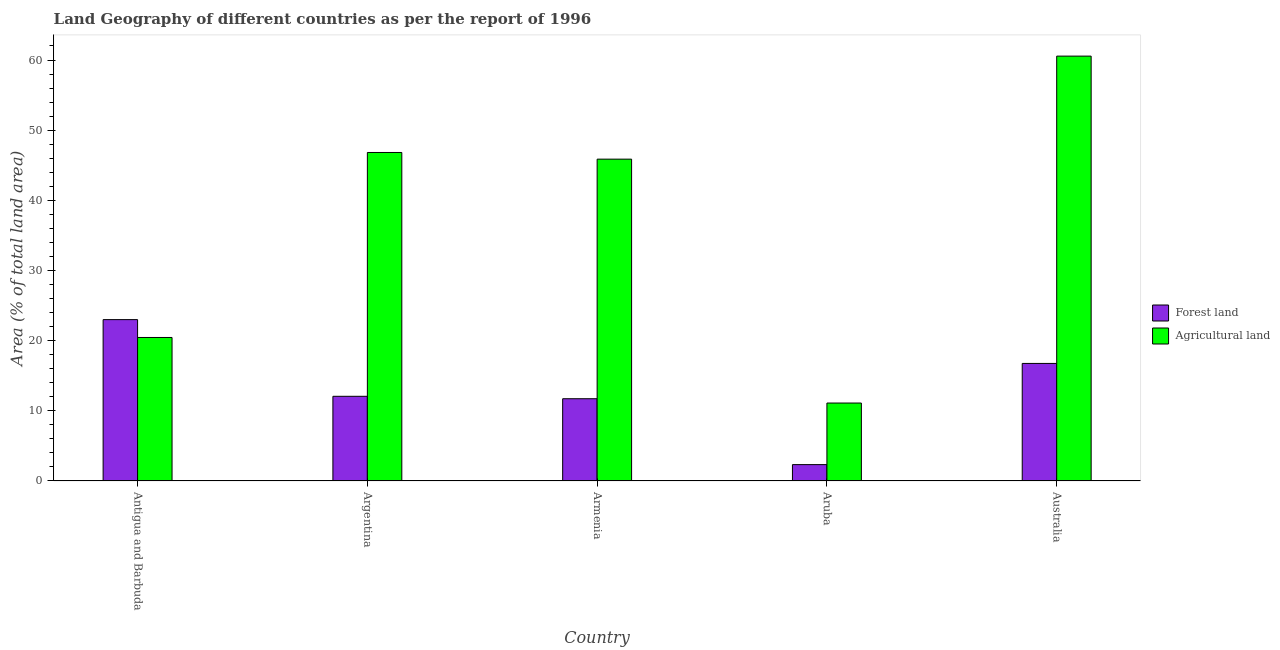How many different coloured bars are there?
Provide a short and direct response. 2. How many groups of bars are there?
Ensure brevity in your answer.  5. Are the number of bars on each tick of the X-axis equal?
Your response must be concise. Yes. What is the label of the 1st group of bars from the left?
Offer a terse response. Antigua and Barbuda. In how many cases, is the number of bars for a given country not equal to the number of legend labels?
Your answer should be very brief. 0. What is the percentage of land area under agriculture in Antigua and Barbuda?
Offer a very short reply. 20.45. Across all countries, what is the minimum percentage of land area under agriculture?
Your answer should be compact. 11.11. In which country was the percentage of land area under forests minimum?
Provide a succinct answer. Aruba. What is the total percentage of land area under agriculture in the graph?
Provide a succinct answer. 184.82. What is the difference between the percentage of land area under agriculture in Antigua and Barbuda and that in Argentina?
Ensure brevity in your answer.  -26.37. What is the difference between the percentage of land area under agriculture in Argentina and the percentage of land area under forests in Armenia?
Your response must be concise. 35.1. What is the average percentage of land area under agriculture per country?
Offer a very short reply. 36.96. What is the difference between the percentage of land area under forests and percentage of land area under agriculture in Armenia?
Your answer should be compact. -34.15. What is the ratio of the percentage of land area under agriculture in Antigua and Barbuda to that in Armenia?
Offer a very short reply. 0.45. Is the percentage of land area under forests in Argentina less than that in Armenia?
Ensure brevity in your answer.  No. What is the difference between the highest and the second highest percentage of land area under forests?
Provide a succinct answer. 6.24. What is the difference between the highest and the lowest percentage of land area under forests?
Ensure brevity in your answer.  20.67. What does the 2nd bar from the left in Antigua and Barbuda represents?
Give a very brief answer. Agricultural land. What does the 2nd bar from the right in Australia represents?
Keep it short and to the point. Forest land. How many bars are there?
Ensure brevity in your answer.  10. Are all the bars in the graph horizontal?
Offer a terse response. No. How many countries are there in the graph?
Your answer should be very brief. 5. Are the values on the major ticks of Y-axis written in scientific E-notation?
Provide a succinct answer. No. How are the legend labels stacked?
Your answer should be compact. Vertical. What is the title of the graph?
Offer a terse response. Land Geography of different countries as per the report of 1996. What is the label or title of the X-axis?
Provide a short and direct response. Country. What is the label or title of the Y-axis?
Your answer should be very brief. Area (% of total land area). What is the Area (% of total land area) of Forest land in Antigua and Barbuda?
Give a very brief answer. 23. What is the Area (% of total land area) of Agricultural land in Antigua and Barbuda?
Make the answer very short. 20.45. What is the Area (% of total land area) in Forest land in Argentina?
Ensure brevity in your answer.  12.07. What is the Area (% of total land area) of Agricultural land in Argentina?
Offer a terse response. 46.82. What is the Area (% of total land area) of Forest land in Armenia?
Ensure brevity in your answer.  11.72. What is the Area (% of total land area) of Agricultural land in Armenia?
Ensure brevity in your answer.  45.87. What is the Area (% of total land area) in Forest land in Aruba?
Your answer should be very brief. 2.33. What is the Area (% of total land area) in Agricultural land in Aruba?
Your answer should be compact. 11.11. What is the Area (% of total land area) of Forest land in Australia?
Give a very brief answer. 16.76. What is the Area (% of total land area) in Agricultural land in Australia?
Your answer should be very brief. 60.56. Across all countries, what is the maximum Area (% of total land area) of Forest land?
Your answer should be very brief. 23. Across all countries, what is the maximum Area (% of total land area) of Agricultural land?
Keep it short and to the point. 60.56. Across all countries, what is the minimum Area (% of total land area) in Forest land?
Provide a short and direct response. 2.33. Across all countries, what is the minimum Area (% of total land area) in Agricultural land?
Your answer should be compact. 11.11. What is the total Area (% of total land area) of Forest land in the graph?
Your response must be concise. 65.88. What is the total Area (% of total land area) in Agricultural land in the graph?
Keep it short and to the point. 184.82. What is the difference between the Area (% of total land area) of Forest land in Antigua and Barbuda and that in Argentina?
Give a very brief answer. 10.93. What is the difference between the Area (% of total land area) of Agricultural land in Antigua and Barbuda and that in Argentina?
Your answer should be compact. -26.37. What is the difference between the Area (% of total land area) of Forest land in Antigua and Barbuda and that in Armenia?
Provide a short and direct response. 11.28. What is the difference between the Area (% of total land area) in Agricultural land in Antigua and Barbuda and that in Armenia?
Provide a short and direct response. -25.42. What is the difference between the Area (% of total land area) of Forest land in Antigua and Barbuda and that in Aruba?
Offer a very short reply. 20.67. What is the difference between the Area (% of total land area) in Agricultural land in Antigua and Barbuda and that in Aruba?
Your response must be concise. 9.34. What is the difference between the Area (% of total land area) of Forest land in Antigua and Barbuda and that in Australia?
Offer a very short reply. 6.24. What is the difference between the Area (% of total land area) in Agricultural land in Antigua and Barbuda and that in Australia?
Your answer should be compact. -40.1. What is the difference between the Area (% of total land area) in Forest land in Argentina and that in Armenia?
Offer a terse response. 0.35. What is the difference between the Area (% of total land area) of Agricultural land in Argentina and that in Armenia?
Give a very brief answer. 0.95. What is the difference between the Area (% of total land area) of Forest land in Argentina and that in Aruba?
Ensure brevity in your answer.  9.74. What is the difference between the Area (% of total land area) of Agricultural land in Argentina and that in Aruba?
Your answer should be compact. 35.71. What is the difference between the Area (% of total land area) in Forest land in Argentina and that in Australia?
Keep it short and to the point. -4.68. What is the difference between the Area (% of total land area) in Agricultural land in Argentina and that in Australia?
Your answer should be very brief. -13.73. What is the difference between the Area (% of total land area) of Forest land in Armenia and that in Aruba?
Ensure brevity in your answer.  9.39. What is the difference between the Area (% of total land area) of Agricultural land in Armenia and that in Aruba?
Ensure brevity in your answer.  34.76. What is the difference between the Area (% of total land area) of Forest land in Armenia and that in Australia?
Ensure brevity in your answer.  -5.03. What is the difference between the Area (% of total land area) in Agricultural land in Armenia and that in Australia?
Make the answer very short. -14.68. What is the difference between the Area (% of total land area) in Forest land in Aruba and that in Australia?
Offer a terse response. -14.42. What is the difference between the Area (% of total land area) in Agricultural land in Aruba and that in Australia?
Offer a terse response. -49.45. What is the difference between the Area (% of total land area) in Forest land in Antigua and Barbuda and the Area (% of total land area) in Agricultural land in Argentina?
Give a very brief answer. -23.82. What is the difference between the Area (% of total land area) in Forest land in Antigua and Barbuda and the Area (% of total land area) in Agricultural land in Armenia?
Your answer should be very brief. -22.87. What is the difference between the Area (% of total land area) of Forest land in Antigua and Barbuda and the Area (% of total land area) of Agricultural land in Aruba?
Your answer should be very brief. 11.89. What is the difference between the Area (% of total land area) of Forest land in Antigua and Barbuda and the Area (% of total land area) of Agricultural land in Australia?
Make the answer very short. -37.56. What is the difference between the Area (% of total land area) of Forest land in Argentina and the Area (% of total land area) of Agricultural land in Armenia?
Give a very brief answer. -33.8. What is the difference between the Area (% of total land area) in Forest land in Argentina and the Area (% of total land area) in Agricultural land in Aruba?
Your response must be concise. 0.96. What is the difference between the Area (% of total land area) of Forest land in Argentina and the Area (% of total land area) of Agricultural land in Australia?
Provide a succinct answer. -48.49. What is the difference between the Area (% of total land area) of Forest land in Armenia and the Area (% of total land area) of Agricultural land in Aruba?
Your answer should be very brief. 0.61. What is the difference between the Area (% of total land area) in Forest land in Armenia and the Area (% of total land area) in Agricultural land in Australia?
Your response must be concise. -48.83. What is the difference between the Area (% of total land area) in Forest land in Aruba and the Area (% of total land area) in Agricultural land in Australia?
Your answer should be very brief. -58.22. What is the average Area (% of total land area) of Forest land per country?
Provide a succinct answer. 13.18. What is the average Area (% of total land area) of Agricultural land per country?
Your response must be concise. 36.96. What is the difference between the Area (% of total land area) of Forest land and Area (% of total land area) of Agricultural land in Antigua and Barbuda?
Offer a very short reply. 2.55. What is the difference between the Area (% of total land area) of Forest land and Area (% of total land area) of Agricultural land in Argentina?
Ensure brevity in your answer.  -34.75. What is the difference between the Area (% of total land area) in Forest land and Area (% of total land area) in Agricultural land in Armenia?
Offer a terse response. -34.15. What is the difference between the Area (% of total land area) of Forest land and Area (% of total land area) of Agricultural land in Aruba?
Make the answer very short. -8.78. What is the difference between the Area (% of total land area) of Forest land and Area (% of total land area) of Agricultural land in Australia?
Provide a short and direct response. -43.8. What is the ratio of the Area (% of total land area) of Forest land in Antigua and Barbuda to that in Argentina?
Your answer should be compact. 1.91. What is the ratio of the Area (% of total land area) of Agricultural land in Antigua and Barbuda to that in Argentina?
Give a very brief answer. 0.44. What is the ratio of the Area (% of total land area) in Forest land in Antigua and Barbuda to that in Armenia?
Provide a short and direct response. 1.96. What is the ratio of the Area (% of total land area) in Agricultural land in Antigua and Barbuda to that in Armenia?
Your answer should be very brief. 0.45. What is the ratio of the Area (% of total land area) in Forest land in Antigua and Barbuda to that in Aruba?
Offer a terse response. 9.86. What is the ratio of the Area (% of total land area) in Agricultural land in Antigua and Barbuda to that in Aruba?
Your answer should be compact. 1.84. What is the ratio of the Area (% of total land area) of Forest land in Antigua and Barbuda to that in Australia?
Make the answer very short. 1.37. What is the ratio of the Area (% of total land area) of Agricultural land in Antigua and Barbuda to that in Australia?
Give a very brief answer. 0.34. What is the ratio of the Area (% of total land area) in Forest land in Argentina to that in Armenia?
Your response must be concise. 1.03. What is the ratio of the Area (% of total land area) of Agricultural land in Argentina to that in Armenia?
Your response must be concise. 1.02. What is the ratio of the Area (% of total land area) in Forest land in Argentina to that in Aruba?
Keep it short and to the point. 5.17. What is the ratio of the Area (% of total land area) in Agricultural land in Argentina to that in Aruba?
Offer a terse response. 4.21. What is the ratio of the Area (% of total land area) of Forest land in Argentina to that in Australia?
Make the answer very short. 0.72. What is the ratio of the Area (% of total land area) in Agricultural land in Argentina to that in Australia?
Ensure brevity in your answer.  0.77. What is the ratio of the Area (% of total land area) of Forest land in Armenia to that in Aruba?
Your answer should be compact. 5.02. What is the ratio of the Area (% of total land area) of Agricultural land in Armenia to that in Aruba?
Ensure brevity in your answer.  4.13. What is the ratio of the Area (% of total land area) of Forest land in Armenia to that in Australia?
Provide a succinct answer. 0.7. What is the ratio of the Area (% of total land area) in Agricultural land in Armenia to that in Australia?
Keep it short and to the point. 0.76. What is the ratio of the Area (% of total land area) of Forest land in Aruba to that in Australia?
Keep it short and to the point. 0.14. What is the ratio of the Area (% of total land area) of Agricultural land in Aruba to that in Australia?
Give a very brief answer. 0.18. What is the difference between the highest and the second highest Area (% of total land area) of Forest land?
Your response must be concise. 6.24. What is the difference between the highest and the second highest Area (% of total land area) of Agricultural land?
Your answer should be very brief. 13.73. What is the difference between the highest and the lowest Area (% of total land area) of Forest land?
Your response must be concise. 20.67. What is the difference between the highest and the lowest Area (% of total land area) in Agricultural land?
Provide a succinct answer. 49.45. 